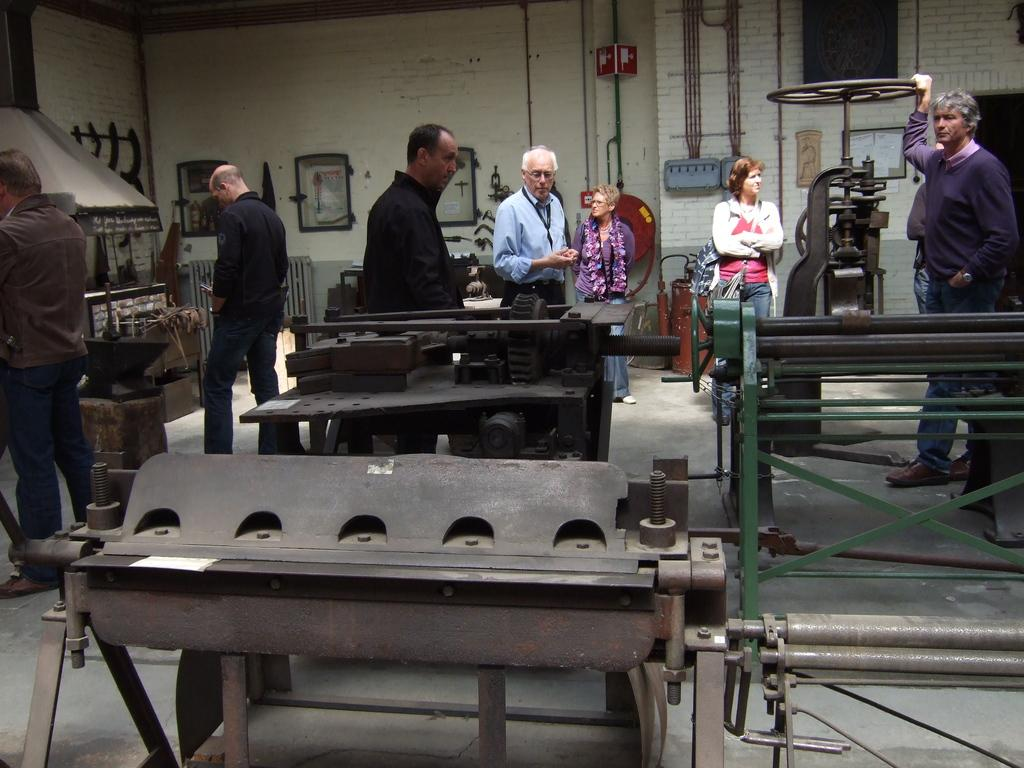What is happening in the image? There are people standing in the image. Can you describe what the man is holding? The man is holding a machine wheel. What else can be seen in the image besides the people? There are machines visible in the image. What is on the wall in the image? There are photo frames on the wall. Where is the throne located in the image? There is no throne present in the image. 